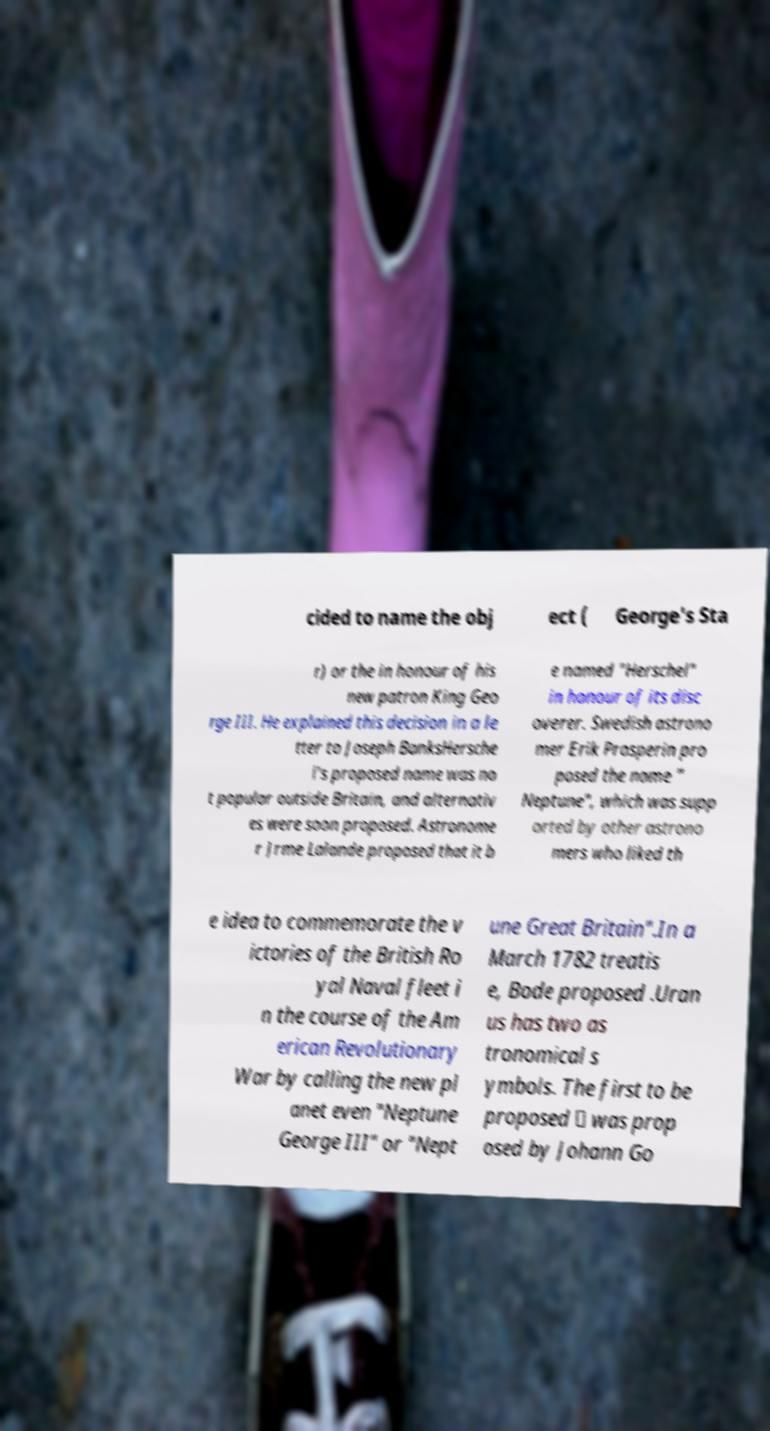Can you read and provide the text displayed in the image?This photo seems to have some interesting text. Can you extract and type it out for me? cided to name the obj ect ( George's Sta r) or the in honour of his new patron King Geo rge III. He explained this decision in a le tter to Joseph BanksHersche l's proposed name was no t popular outside Britain, and alternativ es were soon proposed. Astronome r Jrme Lalande proposed that it b e named "Herschel" in honour of its disc overer. Swedish astrono mer Erik Prosperin pro posed the name " Neptune", which was supp orted by other astrono mers who liked th e idea to commemorate the v ictories of the British Ro yal Naval fleet i n the course of the Am erican Revolutionary War by calling the new pl anet even "Neptune George III" or "Nept une Great Britain".In a March 1782 treatis e, Bode proposed .Uran us has two as tronomical s ymbols. The first to be proposed ⛢ was prop osed by Johann Go 